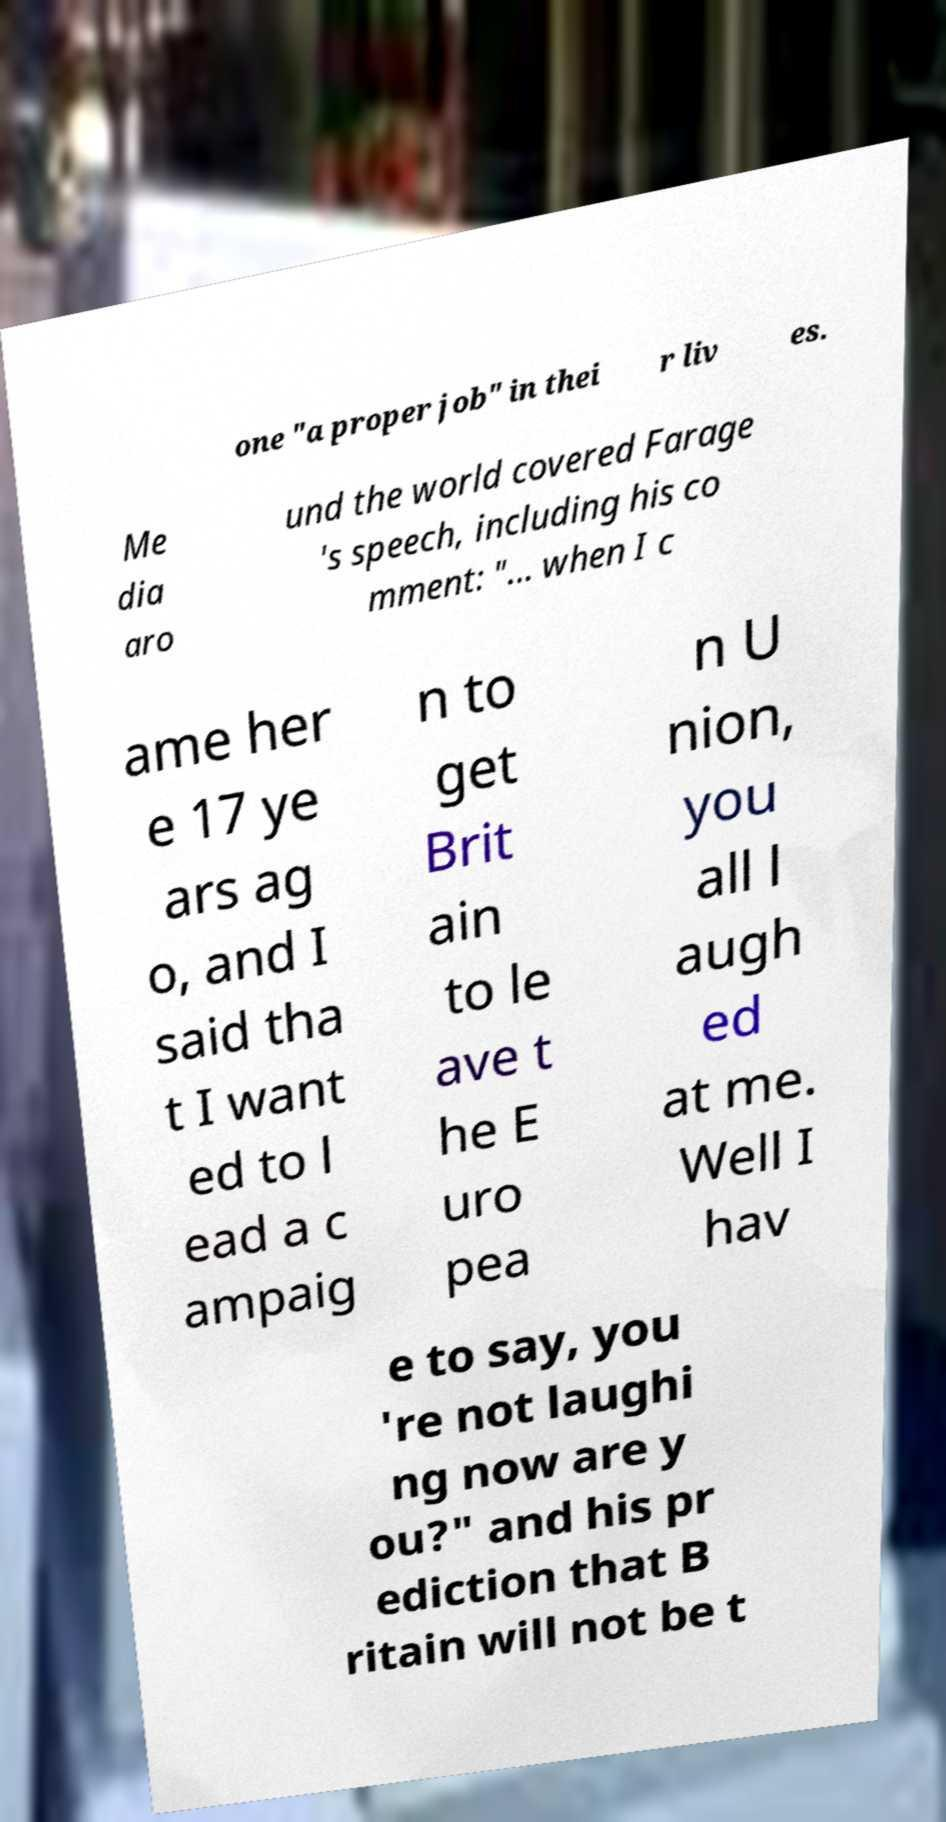Can you accurately transcribe the text from the provided image for me? one "a proper job" in thei r liv es. Me dia aro und the world covered Farage 's speech, including his co mment: "... when I c ame her e 17 ye ars ag o, and I said tha t I want ed to l ead a c ampaig n to get Brit ain to le ave t he E uro pea n U nion, you all l augh ed at me. Well I hav e to say, you 're not laughi ng now are y ou?" and his pr ediction that B ritain will not be t 